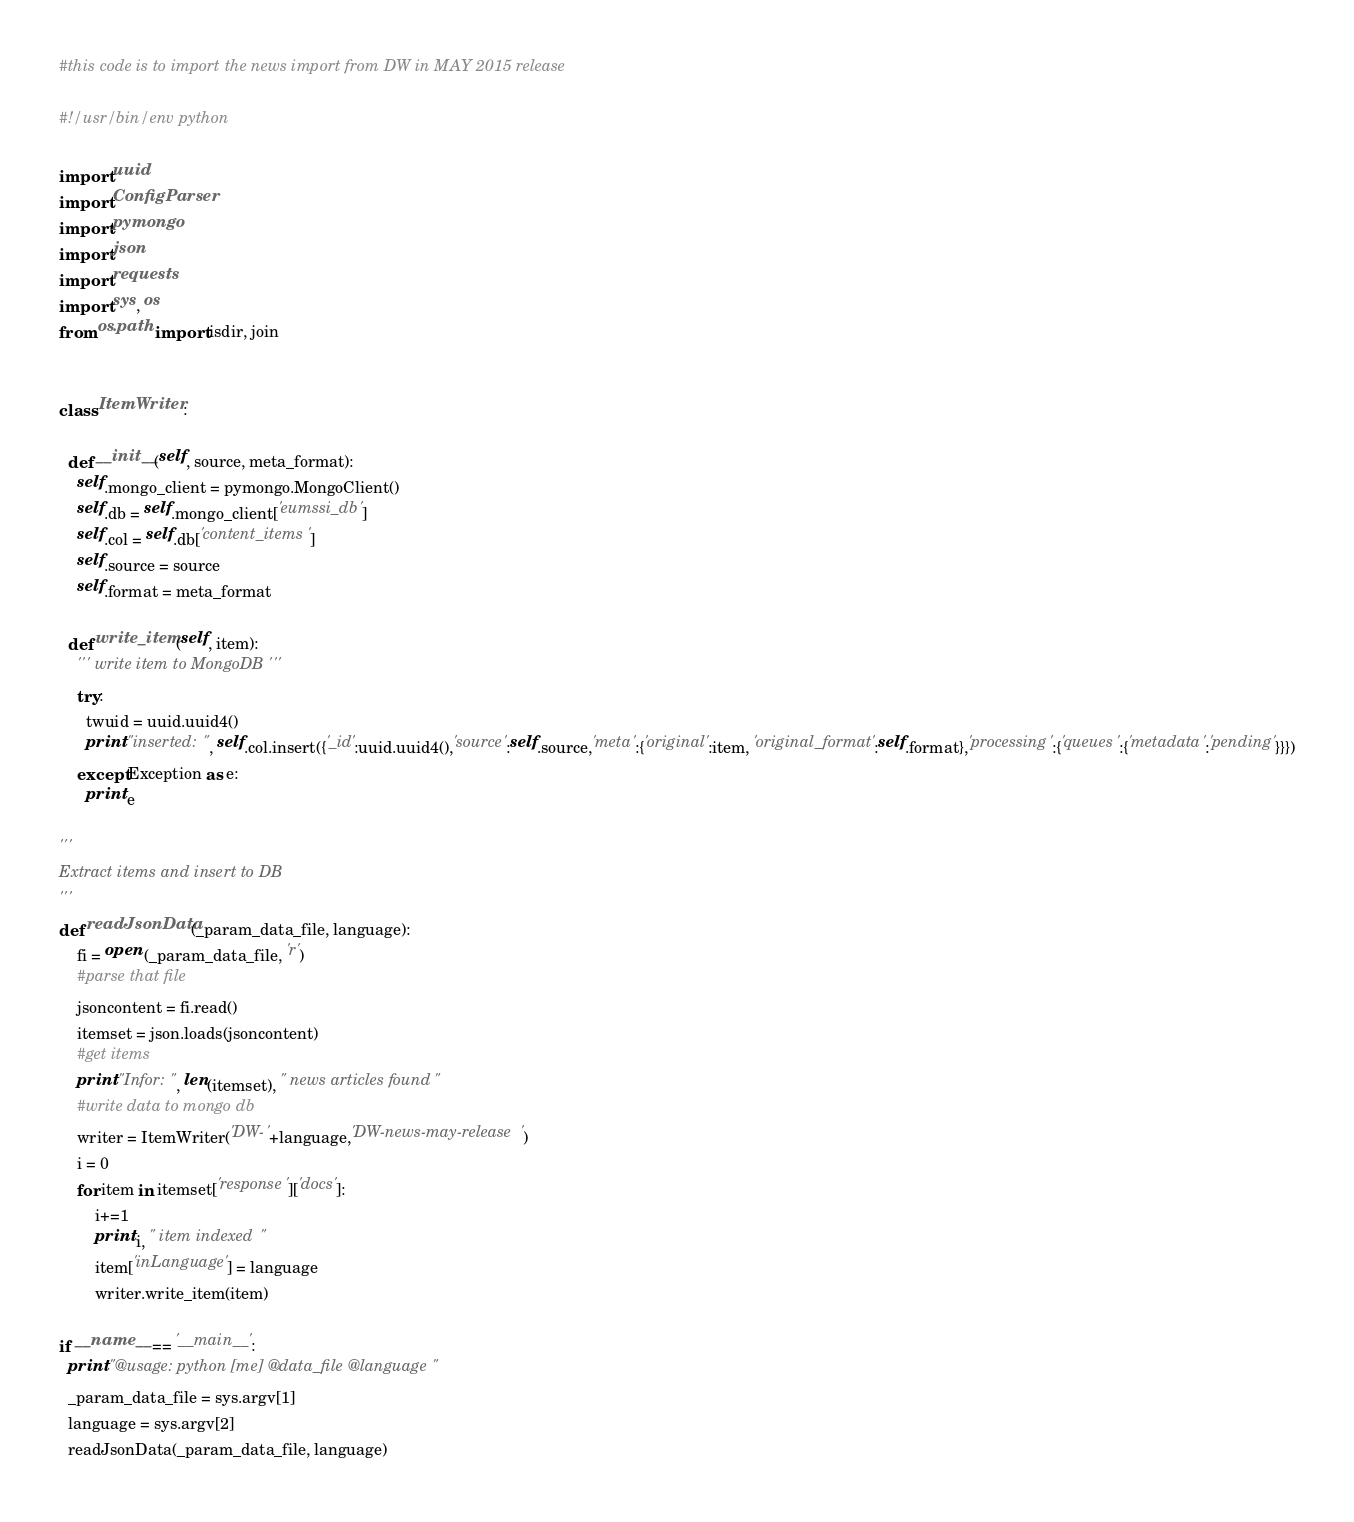Convert code to text. <code><loc_0><loc_0><loc_500><loc_500><_Python_>#this code is to import the news import from DW in MAY 2015 release

#!/usr/bin/env python

import uuid
import ConfigParser
import pymongo
import json
import requests
import sys, os
from os.path import isdir, join


class ItemWriter:

  def __init__(self, source, meta_format):
    self.mongo_client = pymongo.MongoClient()
    self.db = self.mongo_client['eumssi_db']
    self.col = self.db['content_items']
    self.source = source
    self.format = meta_format

  def write_item(self, item):
    ''' write item to MongoDB '''
    try:
      twuid = uuid.uuid4()
      print "inserted: ", self.col.insert({'_id':uuid.uuid4(),'source':self.source,'meta':{'original':item, 'original_format':self.format},'processing':{'queues':{'metadata':'pending'}}})
    except Exception as e:
      print e

'''
Extract items and insert to DB
'''
def readJsonData(_param_data_file, language):    
    fi = open (_param_data_file, 'r')  
    #parse that file
    jsoncontent = fi.read()
    itemset = json.loads(jsoncontent)
    #get items
    print "Infor: ", len(itemset), " news articles found"
    #write data to mongo db
    writer = ItemWriter('DW-'+language,'DW-news-may-release')   
    i = 0
    for item in itemset['response']['docs']:
        i+=1
        print i, " item indexed "
        item['inLanguage'] = language
        writer.write_item(item)

if __name__ == '__main__':
  print "@usage: python [me] @data_file @language"
  _param_data_file = sys.argv[1]
  language = sys.argv[2]
  readJsonData(_param_data_file, language)
</code> 